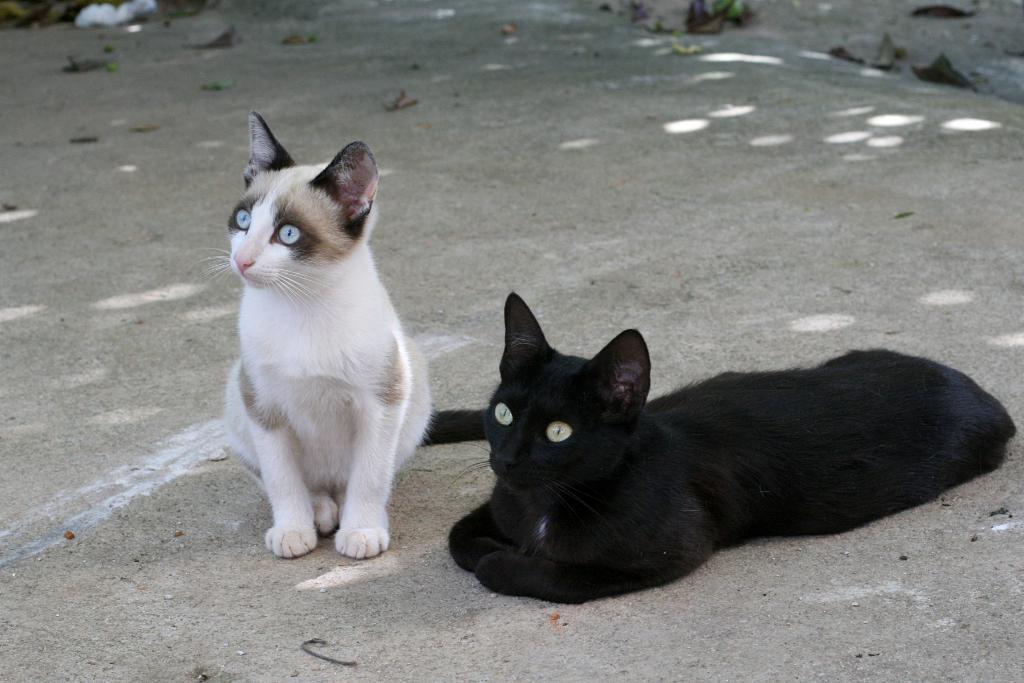In one or two sentences, can you explain what this image depicts? In this image, we can see some cats and the ground with some objects. 